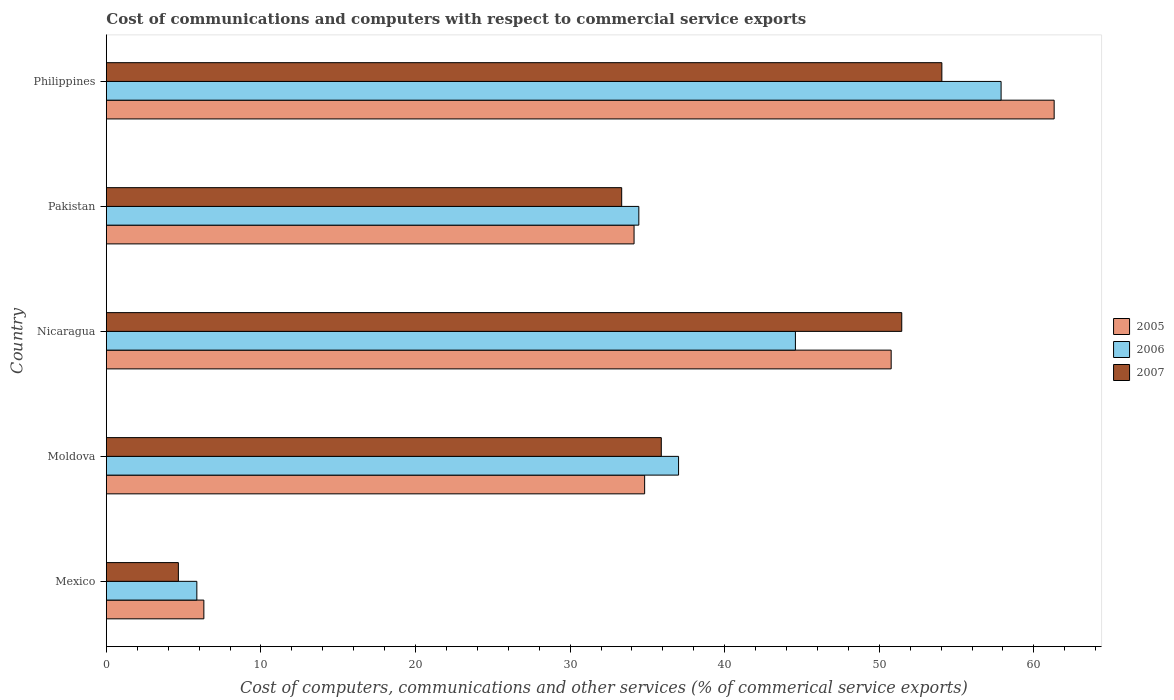Are the number of bars per tick equal to the number of legend labels?
Your answer should be compact. Yes. What is the label of the 5th group of bars from the top?
Provide a succinct answer. Mexico. In how many cases, is the number of bars for a given country not equal to the number of legend labels?
Ensure brevity in your answer.  0. What is the cost of communications and computers in 2007 in Nicaragua?
Offer a very short reply. 51.46. Across all countries, what is the maximum cost of communications and computers in 2006?
Your response must be concise. 57.88. Across all countries, what is the minimum cost of communications and computers in 2006?
Provide a short and direct response. 5.85. What is the total cost of communications and computers in 2007 in the graph?
Ensure brevity in your answer.  179.4. What is the difference between the cost of communications and computers in 2005 in Mexico and that in Pakistan?
Ensure brevity in your answer.  -27.83. What is the difference between the cost of communications and computers in 2006 in Pakistan and the cost of communications and computers in 2005 in Mexico?
Provide a succinct answer. 28.14. What is the average cost of communications and computers in 2005 per country?
Give a very brief answer. 37.47. What is the difference between the cost of communications and computers in 2006 and cost of communications and computers in 2005 in Nicaragua?
Your answer should be very brief. -6.19. In how many countries, is the cost of communications and computers in 2006 greater than 56 %?
Keep it short and to the point. 1. What is the ratio of the cost of communications and computers in 2006 in Mexico to that in Nicaragua?
Ensure brevity in your answer.  0.13. What is the difference between the highest and the second highest cost of communications and computers in 2005?
Offer a terse response. 10.54. What is the difference between the highest and the lowest cost of communications and computers in 2005?
Your answer should be very brief. 55.01. In how many countries, is the cost of communications and computers in 2007 greater than the average cost of communications and computers in 2007 taken over all countries?
Your answer should be very brief. 3. What does the 2nd bar from the top in Moldova represents?
Your answer should be compact. 2006. What does the 3rd bar from the bottom in Pakistan represents?
Give a very brief answer. 2007. Are all the bars in the graph horizontal?
Offer a terse response. Yes. How many countries are there in the graph?
Your response must be concise. 5. What is the difference between two consecutive major ticks on the X-axis?
Your answer should be compact. 10. Are the values on the major ticks of X-axis written in scientific E-notation?
Your answer should be compact. No. Does the graph contain any zero values?
Your response must be concise. No. How many legend labels are there?
Provide a short and direct response. 3. What is the title of the graph?
Keep it short and to the point. Cost of communications and computers with respect to commercial service exports. Does "1967" appear as one of the legend labels in the graph?
Keep it short and to the point. No. What is the label or title of the X-axis?
Ensure brevity in your answer.  Cost of computers, communications and other services (% of commerical service exports). What is the label or title of the Y-axis?
Ensure brevity in your answer.  Country. What is the Cost of computers, communications and other services (% of commerical service exports) in 2005 in Mexico?
Your response must be concise. 6.31. What is the Cost of computers, communications and other services (% of commerical service exports) of 2006 in Mexico?
Your response must be concise. 5.85. What is the Cost of computers, communications and other services (% of commerical service exports) of 2007 in Mexico?
Keep it short and to the point. 4.66. What is the Cost of computers, communications and other services (% of commerical service exports) in 2005 in Moldova?
Your response must be concise. 34.82. What is the Cost of computers, communications and other services (% of commerical service exports) in 2006 in Moldova?
Keep it short and to the point. 37.02. What is the Cost of computers, communications and other services (% of commerical service exports) of 2007 in Moldova?
Keep it short and to the point. 35.9. What is the Cost of computers, communications and other services (% of commerical service exports) of 2005 in Nicaragua?
Make the answer very short. 50.77. What is the Cost of computers, communications and other services (% of commerical service exports) of 2006 in Nicaragua?
Ensure brevity in your answer.  44.58. What is the Cost of computers, communications and other services (% of commerical service exports) of 2007 in Nicaragua?
Provide a short and direct response. 51.46. What is the Cost of computers, communications and other services (% of commerical service exports) in 2005 in Pakistan?
Offer a very short reply. 34.14. What is the Cost of computers, communications and other services (% of commerical service exports) of 2006 in Pakistan?
Provide a short and direct response. 34.45. What is the Cost of computers, communications and other services (% of commerical service exports) in 2007 in Pakistan?
Your answer should be compact. 33.34. What is the Cost of computers, communications and other services (% of commerical service exports) in 2005 in Philippines?
Your answer should be very brief. 61.31. What is the Cost of computers, communications and other services (% of commerical service exports) of 2006 in Philippines?
Make the answer very short. 57.88. What is the Cost of computers, communications and other services (% of commerical service exports) of 2007 in Philippines?
Offer a very short reply. 54.05. Across all countries, what is the maximum Cost of computers, communications and other services (% of commerical service exports) of 2005?
Provide a succinct answer. 61.31. Across all countries, what is the maximum Cost of computers, communications and other services (% of commerical service exports) of 2006?
Make the answer very short. 57.88. Across all countries, what is the maximum Cost of computers, communications and other services (% of commerical service exports) of 2007?
Provide a succinct answer. 54.05. Across all countries, what is the minimum Cost of computers, communications and other services (% of commerical service exports) of 2005?
Your answer should be very brief. 6.31. Across all countries, what is the minimum Cost of computers, communications and other services (% of commerical service exports) of 2006?
Your answer should be very brief. 5.85. Across all countries, what is the minimum Cost of computers, communications and other services (% of commerical service exports) in 2007?
Offer a very short reply. 4.66. What is the total Cost of computers, communications and other services (% of commerical service exports) in 2005 in the graph?
Provide a succinct answer. 187.35. What is the total Cost of computers, communications and other services (% of commerical service exports) of 2006 in the graph?
Give a very brief answer. 179.78. What is the total Cost of computers, communications and other services (% of commerical service exports) of 2007 in the graph?
Your response must be concise. 179.4. What is the difference between the Cost of computers, communications and other services (% of commerical service exports) of 2005 in Mexico and that in Moldova?
Keep it short and to the point. -28.51. What is the difference between the Cost of computers, communications and other services (% of commerical service exports) in 2006 in Mexico and that in Moldova?
Keep it short and to the point. -31.16. What is the difference between the Cost of computers, communications and other services (% of commerical service exports) of 2007 in Mexico and that in Moldova?
Keep it short and to the point. -31.24. What is the difference between the Cost of computers, communications and other services (% of commerical service exports) of 2005 in Mexico and that in Nicaragua?
Your answer should be very brief. -44.46. What is the difference between the Cost of computers, communications and other services (% of commerical service exports) in 2006 in Mexico and that in Nicaragua?
Provide a short and direct response. -38.72. What is the difference between the Cost of computers, communications and other services (% of commerical service exports) in 2007 in Mexico and that in Nicaragua?
Keep it short and to the point. -46.79. What is the difference between the Cost of computers, communications and other services (% of commerical service exports) of 2005 in Mexico and that in Pakistan?
Your answer should be compact. -27.83. What is the difference between the Cost of computers, communications and other services (% of commerical service exports) of 2006 in Mexico and that in Pakistan?
Keep it short and to the point. -28.59. What is the difference between the Cost of computers, communications and other services (% of commerical service exports) in 2007 in Mexico and that in Pakistan?
Ensure brevity in your answer.  -28.68. What is the difference between the Cost of computers, communications and other services (% of commerical service exports) in 2005 in Mexico and that in Philippines?
Keep it short and to the point. -55.01. What is the difference between the Cost of computers, communications and other services (% of commerical service exports) of 2006 in Mexico and that in Philippines?
Provide a succinct answer. -52.03. What is the difference between the Cost of computers, communications and other services (% of commerical service exports) of 2007 in Mexico and that in Philippines?
Keep it short and to the point. -49.39. What is the difference between the Cost of computers, communications and other services (% of commerical service exports) of 2005 in Moldova and that in Nicaragua?
Offer a very short reply. -15.95. What is the difference between the Cost of computers, communications and other services (% of commerical service exports) of 2006 in Moldova and that in Nicaragua?
Offer a very short reply. -7.56. What is the difference between the Cost of computers, communications and other services (% of commerical service exports) in 2007 in Moldova and that in Nicaragua?
Ensure brevity in your answer.  -15.56. What is the difference between the Cost of computers, communications and other services (% of commerical service exports) of 2005 in Moldova and that in Pakistan?
Your answer should be compact. 0.68. What is the difference between the Cost of computers, communications and other services (% of commerical service exports) of 2006 in Moldova and that in Pakistan?
Your response must be concise. 2.57. What is the difference between the Cost of computers, communications and other services (% of commerical service exports) of 2007 in Moldova and that in Pakistan?
Make the answer very short. 2.56. What is the difference between the Cost of computers, communications and other services (% of commerical service exports) in 2005 in Moldova and that in Philippines?
Keep it short and to the point. -26.49. What is the difference between the Cost of computers, communications and other services (% of commerical service exports) of 2006 in Moldova and that in Philippines?
Offer a very short reply. -20.86. What is the difference between the Cost of computers, communications and other services (% of commerical service exports) in 2007 in Moldova and that in Philippines?
Give a very brief answer. -18.15. What is the difference between the Cost of computers, communications and other services (% of commerical service exports) in 2005 in Nicaragua and that in Pakistan?
Your response must be concise. 16.63. What is the difference between the Cost of computers, communications and other services (% of commerical service exports) in 2006 in Nicaragua and that in Pakistan?
Provide a short and direct response. 10.13. What is the difference between the Cost of computers, communications and other services (% of commerical service exports) in 2007 in Nicaragua and that in Pakistan?
Make the answer very short. 18.12. What is the difference between the Cost of computers, communications and other services (% of commerical service exports) of 2005 in Nicaragua and that in Philippines?
Offer a very short reply. -10.54. What is the difference between the Cost of computers, communications and other services (% of commerical service exports) of 2006 in Nicaragua and that in Philippines?
Provide a succinct answer. -13.31. What is the difference between the Cost of computers, communications and other services (% of commerical service exports) of 2007 in Nicaragua and that in Philippines?
Provide a succinct answer. -2.59. What is the difference between the Cost of computers, communications and other services (% of commerical service exports) in 2005 in Pakistan and that in Philippines?
Keep it short and to the point. -27.18. What is the difference between the Cost of computers, communications and other services (% of commerical service exports) in 2006 in Pakistan and that in Philippines?
Offer a very short reply. -23.43. What is the difference between the Cost of computers, communications and other services (% of commerical service exports) of 2007 in Pakistan and that in Philippines?
Provide a short and direct response. -20.71. What is the difference between the Cost of computers, communications and other services (% of commerical service exports) in 2005 in Mexico and the Cost of computers, communications and other services (% of commerical service exports) in 2006 in Moldova?
Ensure brevity in your answer.  -30.71. What is the difference between the Cost of computers, communications and other services (% of commerical service exports) of 2005 in Mexico and the Cost of computers, communications and other services (% of commerical service exports) of 2007 in Moldova?
Your response must be concise. -29.59. What is the difference between the Cost of computers, communications and other services (% of commerical service exports) of 2006 in Mexico and the Cost of computers, communications and other services (% of commerical service exports) of 2007 in Moldova?
Your answer should be very brief. -30.04. What is the difference between the Cost of computers, communications and other services (% of commerical service exports) of 2005 in Mexico and the Cost of computers, communications and other services (% of commerical service exports) of 2006 in Nicaragua?
Offer a very short reply. -38.27. What is the difference between the Cost of computers, communications and other services (% of commerical service exports) of 2005 in Mexico and the Cost of computers, communications and other services (% of commerical service exports) of 2007 in Nicaragua?
Offer a very short reply. -45.15. What is the difference between the Cost of computers, communications and other services (% of commerical service exports) of 2006 in Mexico and the Cost of computers, communications and other services (% of commerical service exports) of 2007 in Nicaragua?
Keep it short and to the point. -45.6. What is the difference between the Cost of computers, communications and other services (% of commerical service exports) in 2005 in Mexico and the Cost of computers, communications and other services (% of commerical service exports) in 2006 in Pakistan?
Your answer should be very brief. -28.14. What is the difference between the Cost of computers, communications and other services (% of commerical service exports) in 2005 in Mexico and the Cost of computers, communications and other services (% of commerical service exports) in 2007 in Pakistan?
Make the answer very short. -27.03. What is the difference between the Cost of computers, communications and other services (% of commerical service exports) of 2006 in Mexico and the Cost of computers, communications and other services (% of commerical service exports) of 2007 in Pakistan?
Give a very brief answer. -27.48. What is the difference between the Cost of computers, communications and other services (% of commerical service exports) of 2005 in Mexico and the Cost of computers, communications and other services (% of commerical service exports) of 2006 in Philippines?
Ensure brevity in your answer.  -51.57. What is the difference between the Cost of computers, communications and other services (% of commerical service exports) of 2005 in Mexico and the Cost of computers, communications and other services (% of commerical service exports) of 2007 in Philippines?
Your answer should be very brief. -47.74. What is the difference between the Cost of computers, communications and other services (% of commerical service exports) of 2006 in Mexico and the Cost of computers, communications and other services (% of commerical service exports) of 2007 in Philippines?
Keep it short and to the point. -48.19. What is the difference between the Cost of computers, communications and other services (% of commerical service exports) in 2005 in Moldova and the Cost of computers, communications and other services (% of commerical service exports) in 2006 in Nicaragua?
Your response must be concise. -9.75. What is the difference between the Cost of computers, communications and other services (% of commerical service exports) in 2005 in Moldova and the Cost of computers, communications and other services (% of commerical service exports) in 2007 in Nicaragua?
Ensure brevity in your answer.  -16.63. What is the difference between the Cost of computers, communications and other services (% of commerical service exports) in 2006 in Moldova and the Cost of computers, communications and other services (% of commerical service exports) in 2007 in Nicaragua?
Give a very brief answer. -14.44. What is the difference between the Cost of computers, communications and other services (% of commerical service exports) of 2005 in Moldova and the Cost of computers, communications and other services (% of commerical service exports) of 2006 in Pakistan?
Give a very brief answer. 0.38. What is the difference between the Cost of computers, communications and other services (% of commerical service exports) in 2005 in Moldova and the Cost of computers, communications and other services (% of commerical service exports) in 2007 in Pakistan?
Offer a very short reply. 1.48. What is the difference between the Cost of computers, communications and other services (% of commerical service exports) of 2006 in Moldova and the Cost of computers, communications and other services (% of commerical service exports) of 2007 in Pakistan?
Provide a succinct answer. 3.68. What is the difference between the Cost of computers, communications and other services (% of commerical service exports) of 2005 in Moldova and the Cost of computers, communications and other services (% of commerical service exports) of 2006 in Philippines?
Your answer should be compact. -23.06. What is the difference between the Cost of computers, communications and other services (% of commerical service exports) in 2005 in Moldova and the Cost of computers, communications and other services (% of commerical service exports) in 2007 in Philippines?
Offer a very short reply. -19.23. What is the difference between the Cost of computers, communications and other services (% of commerical service exports) of 2006 in Moldova and the Cost of computers, communications and other services (% of commerical service exports) of 2007 in Philippines?
Offer a very short reply. -17.03. What is the difference between the Cost of computers, communications and other services (% of commerical service exports) of 2005 in Nicaragua and the Cost of computers, communications and other services (% of commerical service exports) of 2006 in Pakistan?
Offer a terse response. 16.32. What is the difference between the Cost of computers, communications and other services (% of commerical service exports) in 2005 in Nicaragua and the Cost of computers, communications and other services (% of commerical service exports) in 2007 in Pakistan?
Offer a terse response. 17.43. What is the difference between the Cost of computers, communications and other services (% of commerical service exports) of 2006 in Nicaragua and the Cost of computers, communications and other services (% of commerical service exports) of 2007 in Pakistan?
Offer a very short reply. 11.24. What is the difference between the Cost of computers, communications and other services (% of commerical service exports) in 2005 in Nicaragua and the Cost of computers, communications and other services (% of commerical service exports) in 2006 in Philippines?
Your answer should be very brief. -7.11. What is the difference between the Cost of computers, communications and other services (% of commerical service exports) in 2005 in Nicaragua and the Cost of computers, communications and other services (% of commerical service exports) in 2007 in Philippines?
Ensure brevity in your answer.  -3.28. What is the difference between the Cost of computers, communications and other services (% of commerical service exports) of 2006 in Nicaragua and the Cost of computers, communications and other services (% of commerical service exports) of 2007 in Philippines?
Provide a short and direct response. -9.47. What is the difference between the Cost of computers, communications and other services (% of commerical service exports) in 2005 in Pakistan and the Cost of computers, communications and other services (% of commerical service exports) in 2006 in Philippines?
Your answer should be compact. -23.74. What is the difference between the Cost of computers, communications and other services (% of commerical service exports) of 2005 in Pakistan and the Cost of computers, communications and other services (% of commerical service exports) of 2007 in Philippines?
Provide a short and direct response. -19.91. What is the difference between the Cost of computers, communications and other services (% of commerical service exports) of 2006 in Pakistan and the Cost of computers, communications and other services (% of commerical service exports) of 2007 in Philippines?
Keep it short and to the point. -19.6. What is the average Cost of computers, communications and other services (% of commerical service exports) in 2005 per country?
Provide a short and direct response. 37.47. What is the average Cost of computers, communications and other services (% of commerical service exports) of 2006 per country?
Offer a very short reply. 35.96. What is the average Cost of computers, communications and other services (% of commerical service exports) in 2007 per country?
Give a very brief answer. 35.88. What is the difference between the Cost of computers, communications and other services (% of commerical service exports) in 2005 and Cost of computers, communications and other services (% of commerical service exports) in 2006 in Mexico?
Your response must be concise. 0.45. What is the difference between the Cost of computers, communications and other services (% of commerical service exports) in 2005 and Cost of computers, communications and other services (% of commerical service exports) in 2007 in Mexico?
Your answer should be very brief. 1.65. What is the difference between the Cost of computers, communications and other services (% of commerical service exports) of 2006 and Cost of computers, communications and other services (% of commerical service exports) of 2007 in Mexico?
Offer a very short reply. 1.19. What is the difference between the Cost of computers, communications and other services (% of commerical service exports) in 2005 and Cost of computers, communications and other services (% of commerical service exports) in 2006 in Moldova?
Offer a terse response. -2.19. What is the difference between the Cost of computers, communications and other services (% of commerical service exports) in 2005 and Cost of computers, communications and other services (% of commerical service exports) in 2007 in Moldova?
Provide a short and direct response. -1.08. What is the difference between the Cost of computers, communications and other services (% of commerical service exports) in 2006 and Cost of computers, communications and other services (% of commerical service exports) in 2007 in Moldova?
Ensure brevity in your answer.  1.12. What is the difference between the Cost of computers, communications and other services (% of commerical service exports) in 2005 and Cost of computers, communications and other services (% of commerical service exports) in 2006 in Nicaragua?
Provide a succinct answer. 6.19. What is the difference between the Cost of computers, communications and other services (% of commerical service exports) of 2005 and Cost of computers, communications and other services (% of commerical service exports) of 2007 in Nicaragua?
Offer a very short reply. -0.68. What is the difference between the Cost of computers, communications and other services (% of commerical service exports) of 2006 and Cost of computers, communications and other services (% of commerical service exports) of 2007 in Nicaragua?
Your response must be concise. -6.88. What is the difference between the Cost of computers, communications and other services (% of commerical service exports) in 2005 and Cost of computers, communications and other services (% of commerical service exports) in 2006 in Pakistan?
Your response must be concise. -0.31. What is the difference between the Cost of computers, communications and other services (% of commerical service exports) in 2005 and Cost of computers, communications and other services (% of commerical service exports) in 2007 in Pakistan?
Your answer should be very brief. 0.8. What is the difference between the Cost of computers, communications and other services (% of commerical service exports) in 2006 and Cost of computers, communications and other services (% of commerical service exports) in 2007 in Pakistan?
Keep it short and to the point. 1.11. What is the difference between the Cost of computers, communications and other services (% of commerical service exports) of 2005 and Cost of computers, communications and other services (% of commerical service exports) of 2006 in Philippines?
Give a very brief answer. 3.43. What is the difference between the Cost of computers, communications and other services (% of commerical service exports) in 2005 and Cost of computers, communications and other services (% of commerical service exports) in 2007 in Philippines?
Offer a terse response. 7.27. What is the difference between the Cost of computers, communications and other services (% of commerical service exports) of 2006 and Cost of computers, communications and other services (% of commerical service exports) of 2007 in Philippines?
Keep it short and to the point. 3.83. What is the ratio of the Cost of computers, communications and other services (% of commerical service exports) of 2005 in Mexico to that in Moldova?
Keep it short and to the point. 0.18. What is the ratio of the Cost of computers, communications and other services (% of commerical service exports) in 2006 in Mexico to that in Moldova?
Offer a terse response. 0.16. What is the ratio of the Cost of computers, communications and other services (% of commerical service exports) of 2007 in Mexico to that in Moldova?
Keep it short and to the point. 0.13. What is the ratio of the Cost of computers, communications and other services (% of commerical service exports) of 2005 in Mexico to that in Nicaragua?
Your answer should be very brief. 0.12. What is the ratio of the Cost of computers, communications and other services (% of commerical service exports) in 2006 in Mexico to that in Nicaragua?
Make the answer very short. 0.13. What is the ratio of the Cost of computers, communications and other services (% of commerical service exports) in 2007 in Mexico to that in Nicaragua?
Your answer should be very brief. 0.09. What is the ratio of the Cost of computers, communications and other services (% of commerical service exports) of 2005 in Mexico to that in Pakistan?
Offer a terse response. 0.18. What is the ratio of the Cost of computers, communications and other services (% of commerical service exports) of 2006 in Mexico to that in Pakistan?
Your answer should be very brief. 0.17. What is the ratio of the Cost of computers, communications and other services (% of commerical service exports) in 2007 in Mexico to that in Pakistan?
Give a very brief answer. 0.14. What is the ratio of the Cost of computers, communications and other services (% of commerical service exports) of 2005 in Mexico to that in Philippines?
Your answer should be very brief. 0.1. What is the ratio of the Cost of computers, communications and other services (% of commerical service exports) in 2006 in Mexico to that in Philippines?
Offer a very short reply. 0.1. What is the ratio of the Cost of computers, communications and other services (% of commerical service exports) of 2007 in Mexico to that in Philippines?
Ensure brevity in your answer.  0.09. What is the ratio of the Cost of computers, communications and other services (% of commerical service exports) of 2005 in Moldova to that in Nicaragua?
Your answer should be compact. 0.69. What is the ratio of the Cost of computers, communications and other services (% of commerical service exports) in 2006 in Moldova to that in Nicaragua?
Offer a terse response. 0.83. What is the ratio of the Cost of computers, communications and other services (% of commerical service exports) in 2007 in Moldova to that in Nicaragua?
Provide a succinct answer. 0.7. What is the ratio of the Cost of computers, communications and other services (% of commerical service exports) in 2005 in Moldova to that in Pakistan?
Your answer should be very brief. 1.02. What is the ratio of the Cost of computers, communications and other services (% of commerical service exports) in 2006 in Moldova to that in Pakistan?
Ensure brevity in your answer.  1.07. What is the ratio of the Cost of computers, communications and other services (% of commerical service exports) in 2007 in Moldova to that in Pakistan?
Offer a terse response. 1.08. What is the ratio of the Cost of computers, communications and other services (% of commerical service exports) of 2005 in Moldova to that in Philippines?
Your response must be concise. 0.57. What is the ratio of the Cost of computers, communications and other services (% of commerical service exports) of 2006 in Moldova to that in Philippines?
Offer a terse response. 0.64. What is the ratio of the Cost of computers, communications and other services (% of commerical service exports) in 2007 in Moldova to that in Philippines?
Your answer should be very brief. 0.66. What is the ratio of the Cost of computers, communications and other services (% of commerical service exports) in 2005 in Nicaragua to that in Pakistan?
Make the answer very short. 1.49. What is the ratio of the Cost of computers, communications and other services (% of commerical service exports) of 2006 in Nicaragua to that in Pakistan?
Offer a very short reply. 1.29. What is the ratio of the Cost of computers, communications and other services (% of commerical service exports) of 2007 in Nicaragua to that in Pakistan?
Your answer should be compact. 1.54. What is the ratio of the Cost of computers, communications and other services (% of commerical service exports) of 2005 in Nicaragua to that in Philippines?
Your answer should be compact. 0.83. What is the ratio of the Cost of computers, communications and other services (% of commerical service exports) in 2006 in Nicaragua to that in Philippines?
Your answer should be very brief. 0.77. What is the ratio of the Cost of computers, communications and other services (% of commerical service exports) in 2007 in Nicaragua to that in Philippines?
Give a very brief answer. 0.95. What is the ratio of the Cost of computers, communications and other services (% of commerical service exports) in 2005 in Pakistan to that in Philippines?
Your response must be concise. 0.56. What is the ratio of the Cost of computers, communications and other services (% of commerical service exports) of 2006 in Pakistan to that in Philippines?
Offer a terse response. 0.6. What is the ratio of the Cost of computers, communications and other services (% of commerical service exports) of 2007 in Pakistan to that in Philippines?
Give a very brief answer. 0.62. What is the difference between the highest and the second highest Cost of computers, communications and other services (% of commerical service exports) of 2005?
Your answer should be very brief. 10.54. What is the difference between the highest and the second highest Cost of computers, communications and other services (% of commerical service exports) of 2006?
Give a very brief answer. 13.31. What is the difference between the highest and the second highest Cost of computers, communications and other services (% of commerical service exports) of 2007?
Give a very brief answer. 2.59. What is the difference between the highest and the lowest Cost of computers, communications and other services (% of commerical service exports) of 2005?
Provide a succinct answer. 55.01. What is the difference between the highest and the lowest Cost of computers, communications and other services (% of commerical service exports) in 2006?
Ensure brevity in your answer.  52.03. What is the difference between the highest and the lowest Cost of computers, communications and other services (% of commerical service exports) in 2007?
Keep it short and to the point. 49.39. 